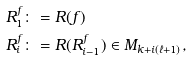<formula> <loc_0><loc_0><loc_500><loc_500>R _ { 1 } ^ { f } & \colon = R ( f ) \\ R _ { i } ^ { f } & \colon = R ( R _ { i - 1 } ^ { f } ) \in M _ { k + i ( \ell + 1 ) } ,</formula> 